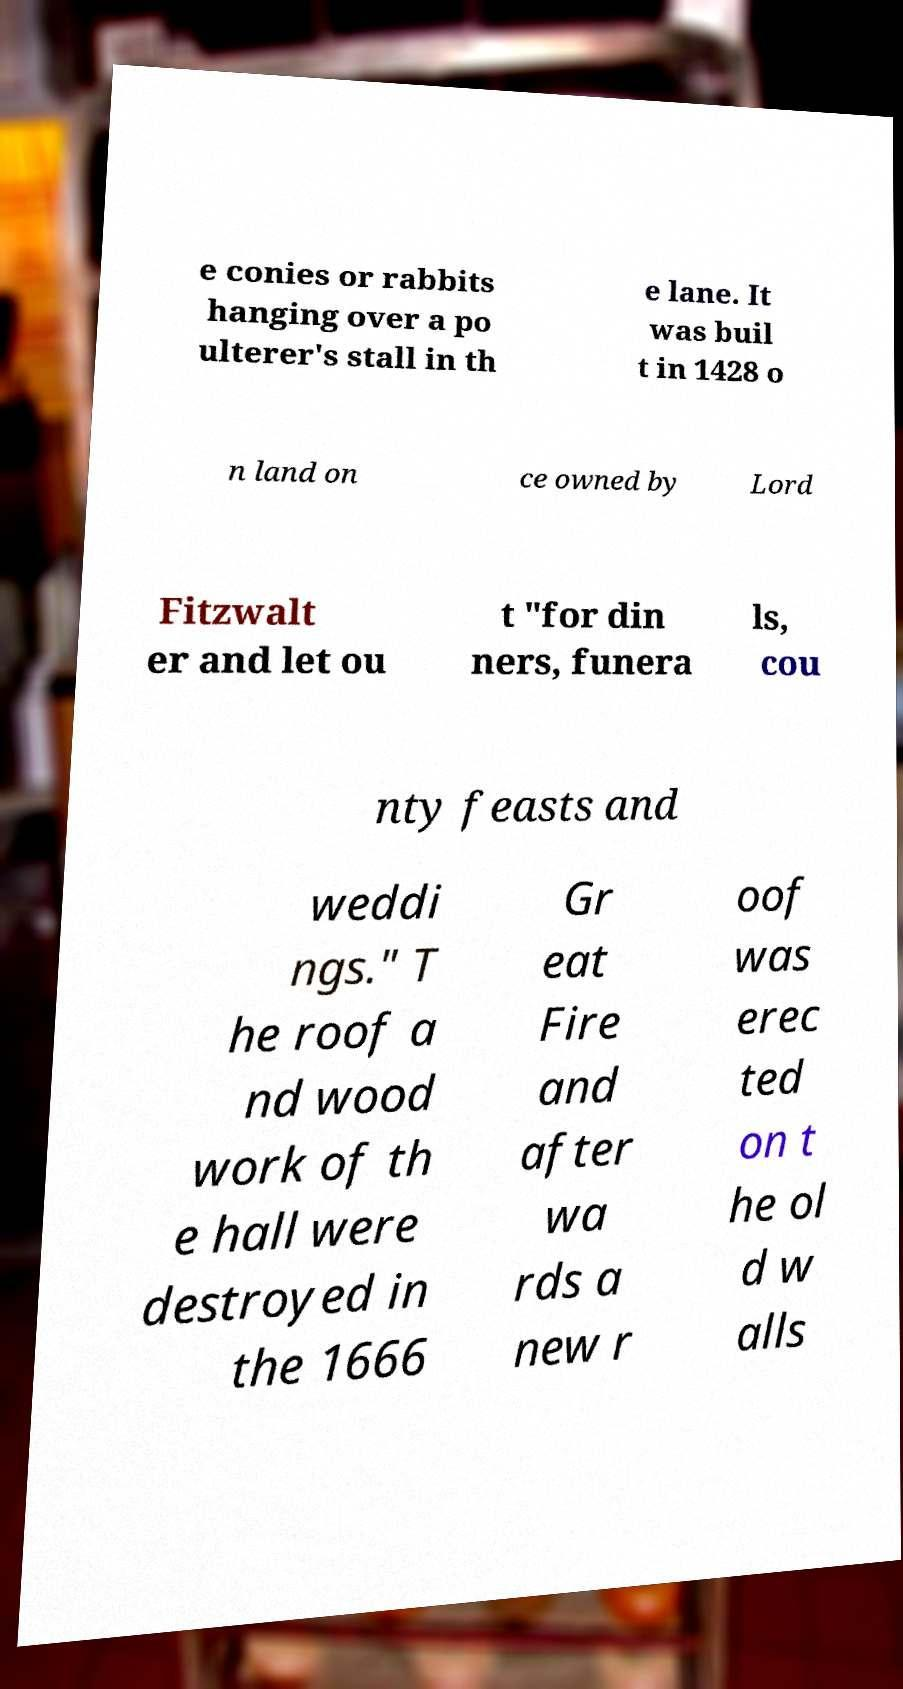Could you assist in decoding the text presented in this image and type it out clearly? e conies or rabbits hanging over a po ulterer's stall in th e lane. It was buil t in 1428 o n land on ce owned by Lord Fitzwalt er and let ou t "for din ners, funera ls, cou nty feasts and weddi ngs." T he roof a nd wood work of th e hall were destroyed in the 1666 Gr eat Fire and after wa rds a new r oof was erec ted on t he ol d w alls 